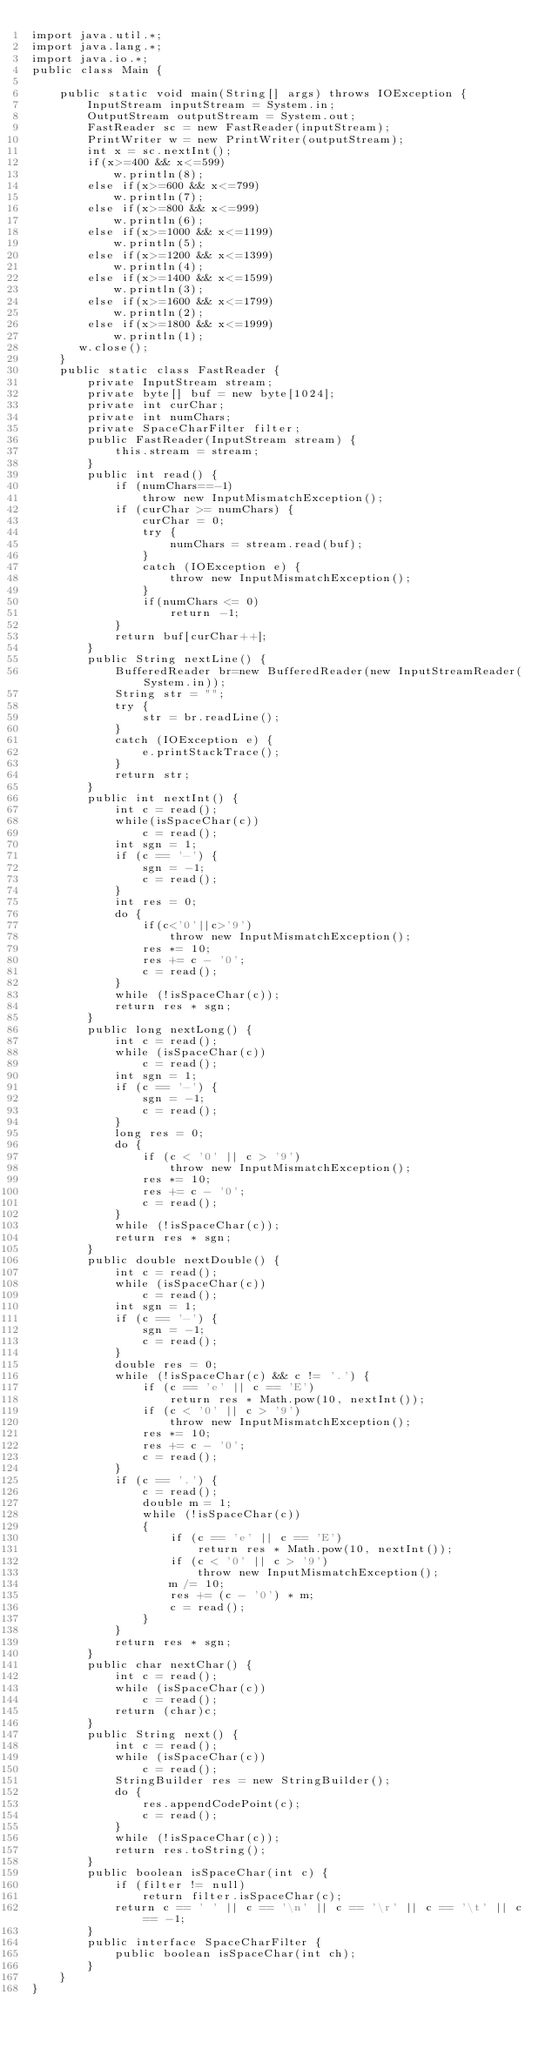Convert code to text. <code><loc_0><loc_0><loc_500><loc_500><_Java_>import java.util.*;
import java.lang.*;
import java.io.*;
public class Main {

	public static void main(String[] args) throws IOException {
		InputStream inputStream = System.in;
        OutputStream outputStream = System.out;
        FastReader sc = new FastReader(inputStream);
        PrintWriter w = new PrintWriter(outputStream);
        int x = sc.nextInt();
        if(x>=400 && x<=599)
        	w.println(8);
        else if(x>=600 && x<=799)
        	w.println(7);
        else if(x>=800 && x<=999)
        	w.println(6);
        else if(x>=1000 && x<=1199)
        	w.println(5);
        else if(x>=1200 && x<=1399)
        	w.println(4);
        else if(x>=1400 && x<=1599)
        	w.println(3);
        else if(x>=1600 && x<=1799)
        	w.println(2);
        else if(x>=1800 && x<=1999)
        	w.println(1);
	   w.close(); 
	}
	public static class FastReader {
        private InputStream stream;
        private byte[] buf = new byte[1024];
        private int curChar;
        private int numChars;
        private SpaceCharFilter filter;
        public FastReader(InputStream stream) {
            this.stream = stream;
        }
        public int read() {
            if (numChars==-1)
                throw new InputMismatchException();
            if (curChar >= numChars) {
                curChar = 0;
                try {
                    numChars = stream.read(buf);
                }
                catch (IOException e) {
                    throw new InputMismatchException();
                }
                if(numChars <= 0)
                    return -1;
            }
            return buf[curChar++];
        }
        public String nextLine() {
            BufferedReader br=new BufferedReader(new InputStreamReader(System.in));
            String str = "";
            try {
                str = br.readLine();
            }
            catch (IOException e) {
                e.printStackTrace();
            }
            return str;
        }
        public int nextInt() {
            int c = read();
            while(isSpaceChar(c))
                c = read();
            int sgn = 1;
            if (c == '-') {
                sgn = -1;
                c = read();
            }
            int res = 0;
            do {
                if(c<'0'||c>'9')
                    throw new InputMismatchException();
                res *= 10;
                res += c - '0';
                c = read();
            }
            while (!isSpaceChar(c));
            return res * sgn;
        }
        public long nextLong() {
            int c = read();
            while (isSpaceChar(c))
                c = read();
            int sgn = 1;
            if (c == '-') {
                sgn = -1;
                c = read();
            }
            long res = 0;
            do {
                if (c < '0' || c > '9')
                    throw new InputMismatchException();
                res *= 10;
                res += c - '0';
                c = read();
            }
            while (!isSpaceChar(c));
            return res * sgn;
        }
        public double nextDouble() {
            int c = read();
            while (isSpaceChar(c))
                c = read();
            int sgn = 1;
            if (c == '-') {
                sgn = -1;
                c = read();
            }
            double res = 0;
            while (!isSpaceChar(c) && c != '.') {
                if (c == 'e' || c == 'E')
                    return res * Math.pow(10, nextInt());
                if (c < '0' || c > '9')
                    throw new InputMismatchException();
                res *= 10;
                res += c - '0';
                c = read();
            }
            if (c == '.') {
                c = read();
                double m = 1;
                while (!isSpaceChar(c))
                {
                    if (c == 'e' || c == 'E')
                        return res * Math.pow(10, nextInt());
                    if (c < '0' || c > '9')
                        throw new InputMismatchException();
                    m /= 10;
                    res += (c - '0') * m;
                    c = read();
                }
            }
            return res * sgn;
        }
        public char nextChar() {
            int c = read();
            while (isSpaceChar(c))
                c = read();
            return (char)c;
        }
        public String next() {
            int c = read();
            while (isSpaceChar(c))
                c = read();
            StringBuilder res = new StringBuilder();
            do {
                res.appendCodePoint(c);
                c = read();
            }
            while (!isSpaceChar(c));
            return res.toString();
        }
        public boolean isSpaceChar(int c) {
            if (filter != null)
                return filter.isSpaceChar(c);
            return c == ' ' || c == '\n' || c == '\r' || c == '\t' || c == -1;
        }
        public interface SpaceCharFilter {
            public boolean isSpaceChar(int ch);
        }
    }
}
</code> 